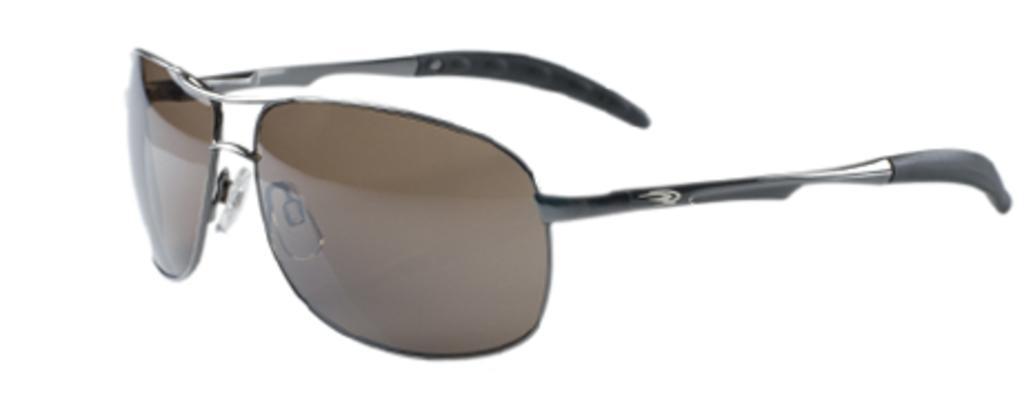How would you summarize this image in a sentence or two? In this image I see the shades over here which is of brown, silver and black in color and I see it is white in the background. 